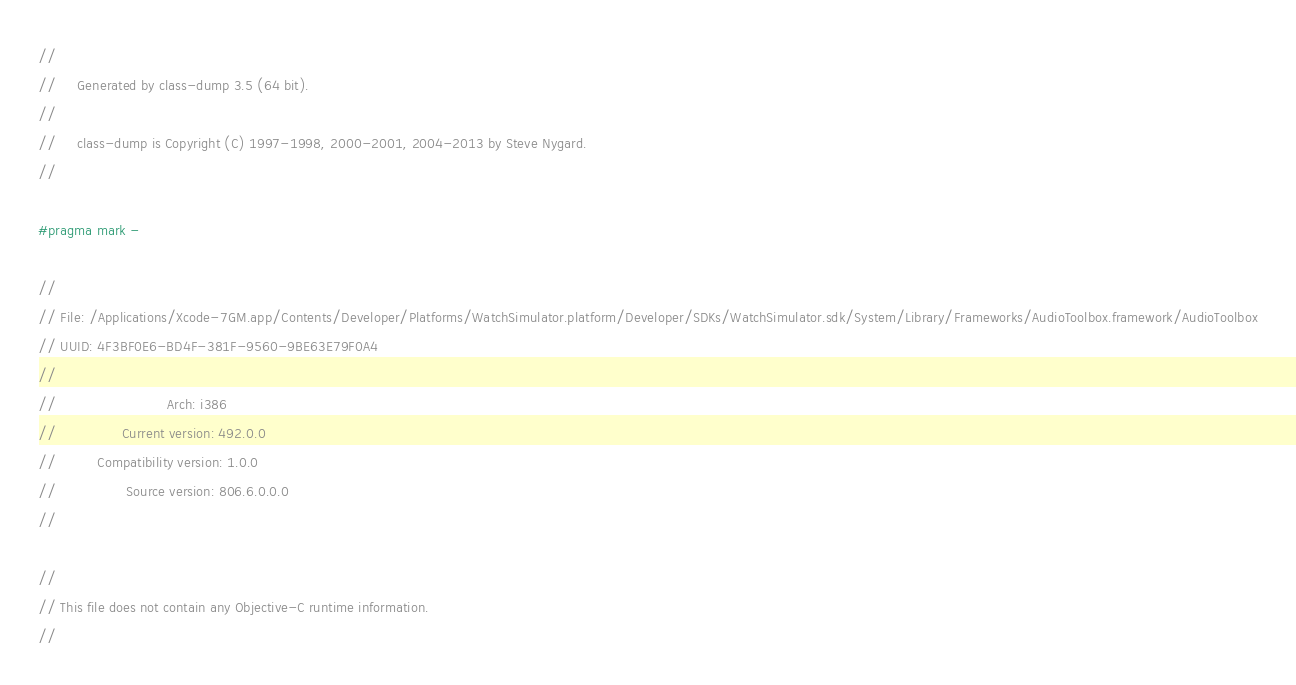<code> <loc_0><loc_0><loc_500><loc_500><_C_>//
//     Generated by class-dump 3.5 (64 bit).
//
//     class-dump is Copyright (C) 1997-1998, 2000-2001, 2004-2013 by Steve Nygard.
//

#pragma mark -

//
// File: /Applications/Xcode-7GM.app/Contents/Developer/Platforms/WatchSimulator.platform/Developer/SDKs/WatchSimulator.sdk/System/Library/Frameworks/AudioToolbox.framework/AudioToolbox
// UUID: 4F3BF0E6-BD4F-381F-9560-9BE63E79F0A4
//
//                           Arch: i386
//                Current version: 492.0.0
//          Compatibility version: 1.0.0
//                 Source version: 806.6.0.0.0
//

//
// This file does not contain any Objective-C runtime information.
//
</code> 